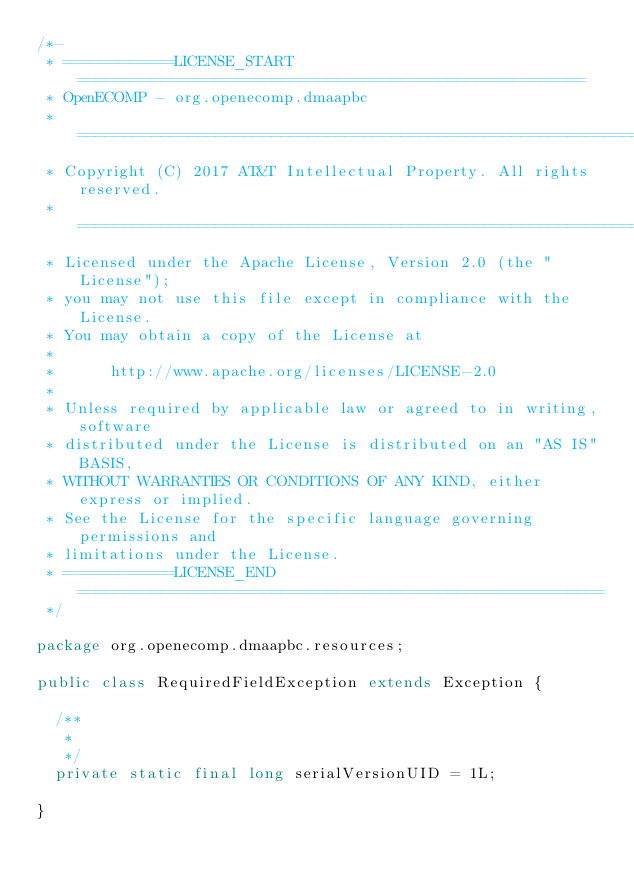Convert code to text. <code><loc_0><loc_0><loc_500><loc_500><_Java_>/*-
 * ============LICENSE_START=======================================================
 * OpenECOMP - org.openecomp.dmaapbc
 * ================================================================================
 * Copyright (C) 2017 AT&T Intellectual Property. All rights reserved.
 * ================================================================================
 * Licensed under the Apache License, Version 2.0 (the "License");
 * you may not use this file except in compliance with the License.
 * You may obtain a copy of the License at
 * 
 *      http://www.apache.org/licenses/LICENSE-2.0
 * 
 * Unless required by applicable law or agreed to in writing, software
 * distributed under the License is distributed on an "AS IS" BASIS,
 * WITHOUT WARRANTIES OR CONDITIONS OF ANY KIND, either express or implied.
 * See the License for the specific language governing permissions and
 * limitations under the License.
 * ============LICENSE_END=========================================================
 */

package org.openecomp.dmaapbc.resources;

public class RequiredFieldException extends Exception {

	/**
	 * 
	 */
	private static final long serialVersionUID = 1L;

}
</code> 